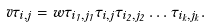<formula> <loc_0><loc_0><loc_500><loc_500>v \tau _ { i , j } = w \tau _ { i _ { 1 } , j _ { 1 } } \tau _ { i , j } \tau _ { i _ { 2 } , j _ { 2 } } \dots \tau _ { i _ { k } , j _ { k } } .</formula> 